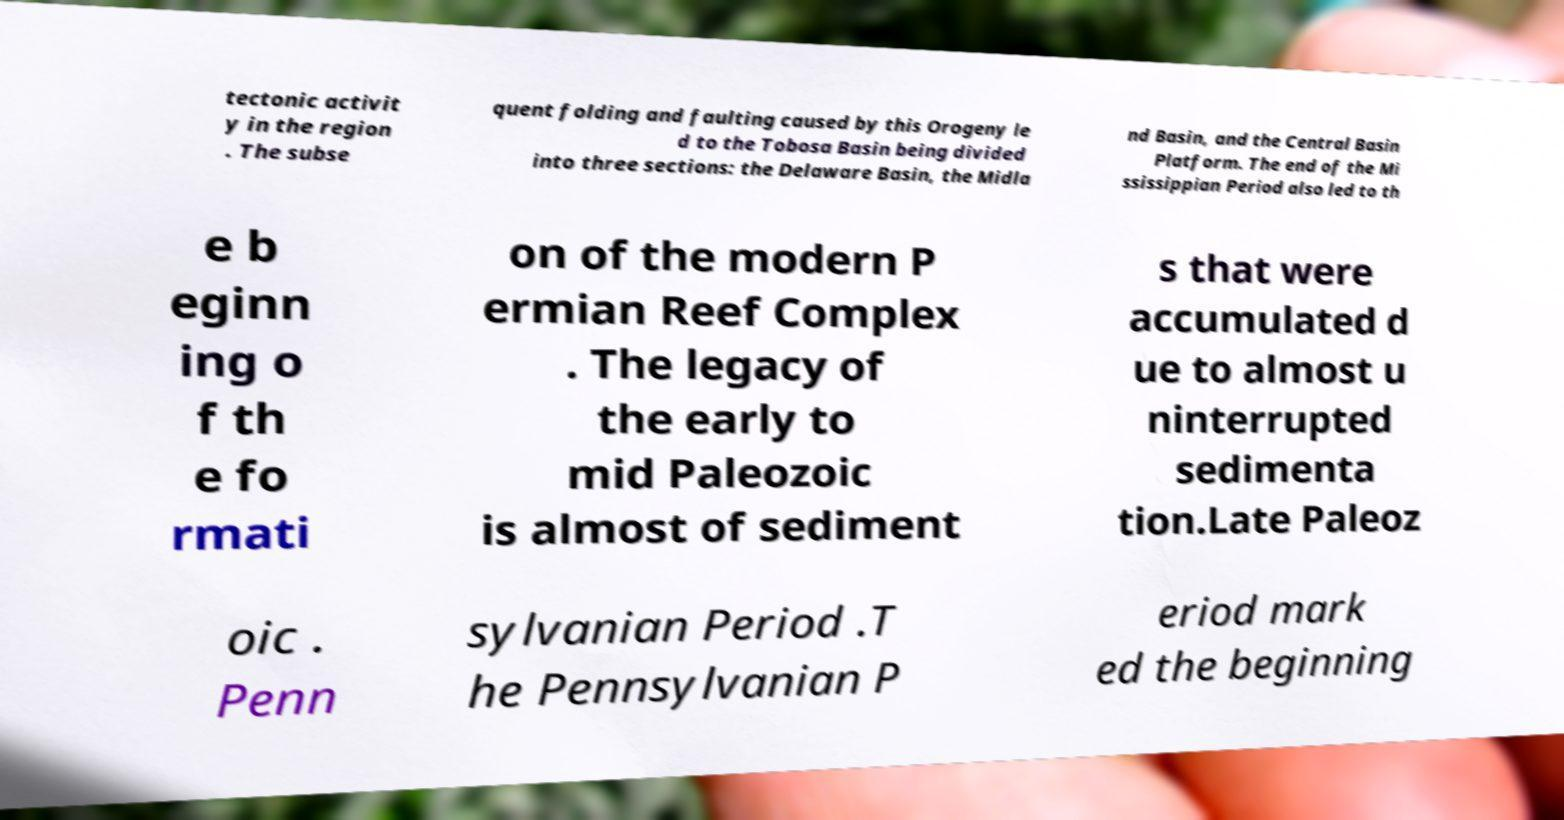What messages or text are displayed in this image? I need them in a readable, typed format. tectonic activit y in the region . The subse quent folding and faulting caused by this Orogeny le d to the Tobosa Basin being divided into three sections: the Delaware Basin, the Midla nd Basin, and the Central Basin Platform. The end of the Mi ssissippian Period also led to th e b eginn ing o f th e fo rmati on of the modern P ermian Reef Complex . The legacy of the early to mid Paleozoic is almost of sediment s that were accumulated d ue to almost u ninterrupted sedimenta tion.Late Paleoz oic . Penn sylvanian Period .T he Pennsylvanian P eriod mark ed the beginning 